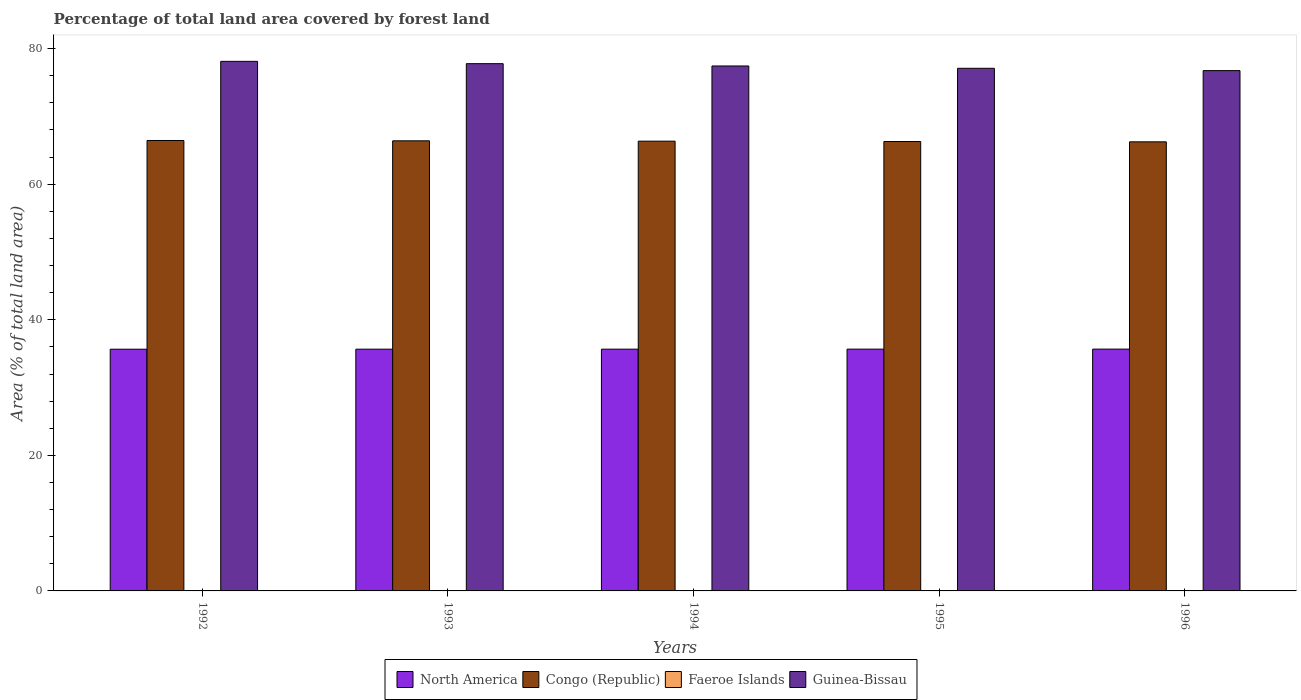How many groups of bars are there?
Provide a short and direct response. 5. Are the number of bars on each tick of the X-axis equal?
Give a very brief answer. Yes. How many bars are there on the 4th tick from the left?
Provide a short and direct response. 4. How many bars are there on the 2nd tick from the right?
Offer a very short reply. 4. What is the label of the 4th group of bars from the left?
Offer a very short reply. 1995. In how many cases, is the number of bars for a given year not equal to the number of legend labels?
Your answer should be compact. 0. What is the percentage of forest land in Congo (Republic) in 1995?
Provide a short and direct response. 66.3. Across all years, what is the maximum percentage of forest land in Congo (Republic)?
Give a very brief answer. 66.45. Across all years, what is the minimum percentage of forest land in North America?
Keep it short and to the point. 35.66. In which year was the percentage of forest land in North America minimum?
Provide a short and direct response. 1992. What is the total percentage of forest land in Faeroe Islands in the graph?
Your answer should be very brief. 0.29. What is the difference between the percentage of forest land in Guinea-Bissau in 1993 and that in 1996?
Offer a very short reply. 1.02. What is the difference between the percentage of forest land in Faeroe Islands in 1993 and the percentage of forest land in Congo (Republic) in 1994?
Your answer should be compact. -66.29. What is the average percentage of forest land in Guinea-Bissau per year?
Your response must be concise. 77.44. In the year 1995, what is the difference between the percentage of forest land in Congo (Republic) and percentage of forest land in Faeroe Islands?
Your answer should be compact. 66.24. In how many years, is the percentage of forest land in Guinea-Bissau greater than 64 %?
Offer a very short reply. 5. What is the ratio of the percentage of forest land in Congo (Republic) in 1992 to that in 1996?
Keep it short and to the point. 1. What is the difference between the highest and the second highest percentage of forest land in Congo (Republic)?
Make the answer very short. 0.05. What is the difference between the highest and the lowest percentage of forest land in Faeroe Islands?
Offer a terse response. 0. Is it the case that in every year, the sum of the percentage of forest land in Congo (Republic) and percentage of forest land in Faeroe Islands is greater than the sum of percentage of forest land in North America and percentage of forest land in Guinea-Bissau?
Give a very brief answer. Yes. What does the 4th bar from the left in 1994 represents?
Give a very brief answer. Guinea-Bissau. What does the 2nd bar from the right in 1996 represents?
Provide a succinct answer. Faeroe Islands. How many bars are there?
Provide a succinct answer. 20. Are all the bars in the graph horizontal?
Your answer should be compact. No. How many legend labels are there?
Your answer should be compact. 4. What is the title of the graph?
Provide a succinct answer. Percentage of total land area covered by forest land. Does "Europe(developing only)" appear as one of the legend labels in the graph?
Make the answer very short. No. What is the label or title of the Y-axis?
Make the answer very short. Area (% of total land area). What is the Area (% of total land area) in North America in 1992?
Give a very brief answer. 35.66. What is the Area (% of total land area) of Congo (Republic) in 1992?
Give a very brief answer. 66.45. What is the Area (% of total land area) in Faeroe Islands in 1992?
Provide a succinct answer. 0.06. What is the Area (% of total land area) of Guinea-Bissau in 1992?
Give a very brief answer. 78.12. What is the Area (% of total land area) in North America in 1993?
Provide a succinct answer. 35.66. What is the Area (% of total land area) of Congo (Republic) in 1993?
Make the answer very short. 66.4. What is the Area (% of total land area) of Faeroe Islands in 1993?
Give a very brief answer. 0.06. What is the Area (% of total land area) of Guinea-Bissau in 1993?
Offer a terse response. 77.78. What is the Area (% of total land area) in North America in 1994?
Your answer should be compact. 35.66. What is the Area (% of total land area) of Congo (Republic) in 1994?
Ensure brevity in your answer.  66.35. What is the Area (% of total land area) in Faeroe Islands in 1994?
Ensure brevity in your answer.  0.06. What is the Area (% of total land area) of Guinea-Bissau in 1994?
Make the answer very short. 77.44. What is the Area (% of total land area) in North America in 1995?
Keep it short and to the point. 35.67. What is the Area (% of total land area) in Congo (Republic) in 1995?
Give a very brief answer. 66.3. What is the Area (% of total land area) in Faeroe Islands in 1995?
Your answer should be compact. 0.06. What is the Area (% of total land area) in Guinea-Bissau in 1995?
Ensure brevity in your answer.  77.1. What is the Area (% of total land area) of North America in 1996?
Provide a succinct answer. 35.67. What is the Area (% of total land area) in Congo (Republic) in 1996?
Make the answer very short. 66.25. What is the Area (% of total land area) in Faeroe Islands in 1996?
Your answer should be compact. 0.06. What is the Area (% of total land area) of Guinea-Bissau in 1996?
Provide a succinct answer. 76.76. Across all years, what is the maximum Area (% of total land area) in North America?
Your answer should be compact. 35.67. Across all years, what is the maximum Area (% of total land area) of Congo (Republic)?
Provide a succinct answer. 66.45. Across all years, what is the maximum Area (% of total land area) in Faeroe Islands?
Your answer should be compact. 0.06. Across all years, what is the maximum Area (% of total land area) in Guinea-Bissau?
Your response must be concise. 78.12. Across all years, what is the minimum Area (% of total land area) in North America?
Offer a terse response. 35.66. Across all years, what is the minimum Area (% of total land area) in Congo (Republic)?
Your answer should be compact. 66.25. Across all years, what is the minimum Area (% of total land area) in Faeroe Islands?
Offer a terse response. 0.06. Across all years, what is the minimum Area (% of total land area) in Guinea-Bissau?
Your answer should be very brief. 76.76. What is the total Area (% of total land area) in North America in the graph?
Provide a succinct answer. 178.32. What is the total Area (% of total land area) in Congo (Republic) in the graph?
Your answer should be compact. 331.74. What is the total Area (% of total land area) in Faeroe Islands in the graph?
Keep it short and to the point. 0.29. What is the total Area (% of total land area) of Guinea-Bissau in the graph?
Keep it short and to the point. 387.2. What is the difference between the Area (% of total land area) in North America in 1992 and that in 1993?
Offer a terse response. -0. What is the difference between the Area (% of total land area) in Congo (Republic) in 1992 and that in 1993?
Make the answer very short. 0.05. What is the difference between the Area (% of total land area) of Faeroe Islands in 1992 and that in 1993?
Your answer should be very brief. 0. What is the difference between the Area (% of total land area) in Guinea-Bissau in 1992 and that in 1993?
Give a very brief answer. 0.34. What is the difference between the Area (% of total land area) in North America in 1992 and that in 1994?
Ensure brevity in your answer.  -0.01. What is the difference between the Area (% of total land area) in Congo (Republic) in 1992 and that in 1994?
Provide a short and direct response. 0.1. What is the difference between the Area (% of total land area) of Guinea-Bissau in 1992 and that in 1994?
Your answer should be very brief. 0.68. What is the difference between the Area (% of total land area) of North America in 1992 and that in 1995?
Make the answer very short. -0.01. What is the difference between the Area (% of total land area) in Congo (Republic) in 1992 and that in 1995?
Your response must be concise. 0.15. What is the difference between the Area (% of total land area) of Guinea-Bissau in 1992 and that in 1995?
Make the answer very short. 1.02. What is the difference between the Area (% of total land area) of North America in 1992 and that in 1996?
Your answer should be very brief. -0.01. What is the difference between the Area (% of total land area) in Congo (Republic) in 1992 and that in 1996?
Your answer should be compact. 0.2. What is the difference between the Area (% of total land area) in Faeroe Islands in 1992 and that in 1996?
Provide a short and direct response. 0. What is the difference between the Area (% of total land area) in Guinea-Bissau in 1992 and that in 1996?
Your answer should be very brief. 1.37. What is the difference between the Area (% of total land area) of North America in 1993 and that in 1994?
Provide a short and direct response. -0. What is the difference between the Area (% of total land area) of Congo (Republic) in 1993 and that in 1994?
Your answer should be compact. 0.05. What is the difference between the Area (% of total land area) of Faeroe Islands in 1993 and that in 1994?
Make the answer very short. 0. What is the difference between the Area (% of total land area) of Guinea-Bissau in 1993 and that in 1994?
Give a very brief answer. 0.34. What is the difference between the Area (% of total land area) in North America in 1993 and that in 1995?
Your answer should be compact. -0.01. What is the difference between the Area (% of total land area) of Congo (Republic) in 1993 and that in 1995?
Ensure brevity in your answer.  0.1. What is the difference between the Area (% of total land area) of Guinea-Bissau in 1993 and that in 1995?
Make the answer very short. 0.68. What is the difference between the Area (% of total land area) of North America in 1993 and that in 1996?
Your answer should be very brief. -0.01. What is the difference between the Area (% of total land area) in Congo (Republic) in 1993 and that in 1996?
Keep it short and to the point. 0.15. What is the difference between the Area (% of total land area) of Guinea-Bissau in 1993 and that in 1996?
Provide a succinct answer. 1.02. What is the difference between the Area (% of total land area) in North America in 1994 and that in 1995?
Offer a very short reply. -0. What is the difference between the Area (% of total land area) of Congo (Republic) in 1994 and that in 1995?
Your response must be concise. 0.05. What is the difference between the Area (% of total land area) of Faeroe Islands in 1994 and that in 1995?
Your response must be concise. 0. What is the difference between the Area (% of total land area) in Guinea-Bissau in 1994 and that in 1995?
Ensure brevity in your answer.  0.34. What is the difference between the Area (% of total land area) of North America in 1994 and that in 1996?
Provide a succinct answer. -0.01. What is the difference between the Area (% of total land area) in Congo (Republic) in 1994 and that in 1996?
Your response must be concise. 0.1. What is the difference between the Area (% of total land area) in Guinea-Bissau in 1994 and that in 1996?
Offer a terse response. 0.68. What is the difference between the Area (% of total land area) in North America in 1995 and that in 1996?
Ensure brevity in your answer.  -0. What is the difference between the Area (% of total land area) of Congo (Republic) in 1995 and that in 1996?
Your answer should be compact. 0.05. What is the difference between the Area (% of total land area) in Faeroe Islands in 1995 and that in 1996?
Provide a succinct answer. 0. What is the difference between the Area (% of total land area) in Guinea-Bissau in 1995 and that in 1996?
Ensure brevity in your answer.  0.34. What is the difference between the Area (% of total land area) of North America in 1992 and the Area (% of total land area) of Congo (Republic) in 1993?
Ensure brevity in your answer.  -30.74. What is the difference between the Area (% of total land area) of North America in 1992 and the Area (% of total land area) of Faeroe Islands in 1993?
Offer a very short reply. 35.6. What is the difference between the Area (% of total land area) of North America in 1992 and the Area (% of total land area) of Guinea-Bissau in 1993?
Your response must be concise. -42.12. What is the difference between the Area (% of total land area) in Congo (Republic) in 1992 and the Area (% of total land area) in Faeroe Islands in 1993?
Provide a succinct answer. 66.39. What is the difference between the Area (% of total land area) of Congo (Republic) in 1992 and the Area (% of total land area) of Guinea-Bissau in 1993?
Keep it short and to the point. -11.33. What is the difference between the Area (% of total land area) of Faeroe Islands in 1992 and the Area (% of total land area) of Guinea-Bissau in 1993?
Provide a short and direct response. -77.72. What is the difference between the Area (% of total land area) in North America in 1992 and the Area (% of total land area) in Congo (Republic) in 1994?
Keep it short and to the point. -30.69. What is the difference between the Area (% of total land area) of North America in 1992 and the Area (% of total land area) of Faeroe Islands in 1994?
Offer a terse response. 35.6. What is the difference between the Area (% of total land area) of North America in 1992 and the Area (% of total land area) of Guinea-Bissau in 1994?
Keep it short and to the point. -41.78. What is the difference between the Area (% of total land area) of Congo (Republic) in 1992 and the Area (% of total land area) of Faeroe Islands in 1994?
Give a very brief answer. 66.39. What is the difference between the Area (% of total land area) of Congo (Republic) in 1992 and the Area (% of total land area) of Guinea-Bissau in 1994?
Make the answer very short. -10.99. What is the difference between the Area (% of total land area) of Faeroe Islands in 1992 and the Area (% of total land area) of Guinea-Bissau in 1994?
Offer a very short reply. -77.38. What is the difference between the Area (% of total land area) of North America in 1992 and the Area (% of total land area) of Congo (Republic) in 1995?
Offer a terse response. -30.64. What is the difference between the Area (% of total land area) in North America in 1992 and the Area (% of total land area) in Faeroe Islands in 1995?
Give a very brief answer. 35.6. What is the difference between the Area (% of total land area) in North America in 1992 and the Area (% of total land area) in Guinea-Bissau in 1995?
Give a very brief answer. -41.44. What is the difference between the Area (% of total land area) of Congo (Republic) in 1992 and the Area (% of total land area) of Faeroe Islands in 1995?
Ensure brevity in your answer.  66.39. What is the difference between the Area (% of total land area) of Congo (Republic) in 1992 and the Area (% of total land area) of Guinea-Bissau in 1995?
Keep it short and to the point. -10.65. What is the difference between the Area (% of total land area) in Faeroe Islands in 1992 and the Area (% of total land area) in Guinea-Bissau in 1995?
Give a very brief answer. -77.04. What is the difference between the Area (% of total land area) of North America in 1992 and the Area (% of total land area) of Congo (Republic) in 1996?
Your answer should be compact. -30.59. What is the difference between the Area (% of total land area) in North America in 1992 and the Area (% of total land area) in Faeroe Islands in 1996?
Ensure brevity in your answer.  35.6. What is the difference between the Area (% of total land area) of North America in 1992 and the Area (% of total land area) of Guinea-Bissau in 1996?
Your response must be concise. -41.1. What is the difference between the Area (% of total land area) of Congo (Republic) in 1992 and the Area (% of total land area) of Faeroe Islands in 1996?
Provide a succinct answer. 66.39. What is the difference between the Area (% of total land area) of Congo (Republic) in 1992 and the Area (% of total land area) of Guinea-Bissau in 1996?
Make the answer very short. -10.31. What is the difference between the Area (% of total land area) of Faeroe Islands in 1992 and the Area (% of total land area) of Guinea-Bissau in 1996?
Offer a very short reply. -76.7. What is the difference between the Area (% of total land area) in North America in 1993 and the Area (% of total land area) in Congo (Republic) in 1994?
Your response must be concise. -30.69. What is the difference between the Area (% of total land area) of North America in 1993 and the Area (% of total land area) of Faeroe Islands in 1994?
Ensure brevity in your answer.  35.6. What is the difference between the Area (% of total land area) in North America in 1993 and the Area (% of total land area) in Guinea-Bissau in 1994?
Ensure brevity in your answer.  -41.78. What is the difference between the Area (% of total land area) of Congo (Republic) in 1993 and the Area (% of total land area) of Faeroe Islands in 1994?
Your response must be concise. 66.34. What is the difference between the Area (% of total land area) of Congo (Republic) in 1993 and the Area (% of total land area) of Guinea-Bissau in 1994?
Provide a short and direct response. -11.04. What is the difference between the Area (% of total land area) of Faeroe Islands in 1993 and the Area (% of total land area) of Guinea-Bissau in 1994?
Provide a short and direct response. -77.38. What is the difference between the Area (% of total land area) in North America in 1993 and the Area (% of total land area) in Congo (Republic) in 1995?
Provide a short and direct response. -30.64. What is the difference between the Area (% of total land area) of North America in 1993 and the Area (% of total land area) of Faeroe Islands in 1995?
Your answer should be compact. 35.6. What is the difference between the Area (% of total land area) in North America in 1993 and the Area (% of total land area) in Guinea-Bissau in 1995?
Ensure brevity in your answer.  -41.44. What is the difference between the Area (% of total land area) of Congo (Republic) in 1993 and the Area (% of total land area) of Faeroe Islands in 1995?
Your answer should be compact. 66.34. What is the difference between the Area (% of total land area) of Congo (Republic) in 1993 and the Area (% of total land area) of Guinea-Bissau in 1995?
Provide a short and direct response. -10.7. What is the difference between the Area (% of total land area) of Faeroe Islands in 1993 and the Area (% of total land area) of Guinea-Bissau in 1995?
Your answer should be compact. -77.04. What is the difference between the Area (% of total land area) in North America in 1993 and the Area (% of total land area) in Congo (Republic) in 1996?
Offer a terse response. -30.59. What is the difference between the Area (% of total land area) of North America in 1993 and the Area (% of total land area) of Faeroe Islands in 1996?
Offer a terse response. 35.6. What is the difference between the Area (% of total land area) in North America in 1993 and the Area (% of total land area) in Guinea-Bissau in 1996?
Your response must be concise. -41.1. What is the difference between the Area (% of total land area) in Congo (Republic) in 1993 and the Area (% of total land area) in Faeroe Islands in 1996?
Offer a terse response. 66.34. What is the difference between the Area (% of total land area) in Congo (Republic) in 1993 and the Area (% of total land area) in Guinea-Bissau in 1996?
Offer a very short reply. -10.36. What is the difference between the Area (% of total land area) in Faeroe Islands in 1993 and the Area (% of total land area) in Guinea-Bissau in 1996?
Give a very brief answer. -76.7. What is the difference between the Area (% of total land area) of North America in 1994 and the Area (% of total land area) of Congo (Republic) in 1995?
Keep it short and to the point. -30.63. What is the difference between the Area (% of total land area) of North America in 1994 and the Area (% of total land area) of Faeroe Islands in 1995?
Give a very brief answer. 35.61. What is the difference between the Area (% of total land area) of North America in 1994 and the Area (% of total land area) of Guinea-Bissau in 1995?
Offer a terse response. -41.43. What is the difference between the Area (% of total land area) of Congo (Republic) in 1994 and the Area (% of total land area) of Faeroe Islands in 1995?
Offer a very short reply. 66.29. What is the difference between the Area (% of total land area) in Congo (Republic) in 1994 and the Area (% of total land area) in Guinea-Bissau in 1995?
Give a very brief answer. -10.75. What is the difference between the Area (% of total land area) of Faeroe Islands in 1994 and the Area (% of total land area) of Guinea-Bissau in 1995?
Keep it short and to the point. -77.04. What is the difference between the Area (% of total land area) of North America in 1994 and the Area (% of total land area) of Congo (Republic) in 1996?
Give a very brief answer. -30.58. What is the difference between the Area (% of total land area) in North America in 1994 and the Area (% of total land area) in Faeroe Islands in 1996?
Offer a terse response. 35.61. What is the difference between the Area (% of total land area) in North America in 1994 and the Area (% of total land area) in Guinea-Bissau in 1996?
Make the answer very short. -41.09. What is the difference between the Area (% of total land area) in Congo (Republic) in 1994 and the Area (% of total land area) in Faeroe Islands in 1996?
Keep it short and to the point. 66.29. What is the difference between the Area (% of total land area) in Congo (Republic) in 1994 and the Area (% of total land area) in Guinea-Bissau in 1996?
Offer a very short reply. -10.41. What is the difference between the Area (% of total land area) of Faeroe Islands in 1994 and the Area (% of total land area) of Guinea-Bissau in 1996?
Keep it short and to the point. -76.7. What is the difference between the Area (% of total land area) of North America in 1995 and the Area (% of total land area) of Congo (Republic) in 1996?
Offer a very short reply. -30.58. What is the difference between the Area (% of total land area) in North America in 1995 and the Area (% of total land area) in Faeroe Islands in 1996?
Offer a very short reply. 35.61. What is the difference between the Area (% of total land area) in North America in 1995 and the Area (% of total land area) in Guinea-Bissau in 1996?
Your answer should be compact. -41.09. What is the difference between the Area (% of total land area) in Congo (Republic) in 1995 and the Area (% of total land area) in Faeroe Islands in 1996?
Your response must be concise. 66.24. What is the difference between the Area (% of total land area) of Congo (Republic) in 1995 and the Area (% of total land area) of Guinea-Bissau in 1996?
Provide a succinct answer. -10.46. What is the difference between the Area (% of total land area) in Faeroe Islands in 1995 and the Area (% of total land area) in Guinea-Bissau in 1996?
Your response must be concise. -76.7. What is the average Area (% of total land area) of North America per year?
Provide a short and direct response. 35.66. What is the average Area (% of total land area) of Congo (Republic) per year?
Offer a very short reply. 66.35. What is the average Area (% of total land area) of Faeroe Islands per year?
Offer a very short reply. 0.06. What is the average Area (% of total land area) of Guinea-Bissau per year?
Offer a terse response. 77.44. In the year 1992, what is the difference between the Area (% of total land area) of North America and Area (% of total land area) of Congo (Republic)?
Your response must be concise. -30.79. In the year 1992, what is the difference between the Area (% of total land area) in North America and Area (% of total land area) in Faeroe Islands?
Make the answer very short. 35.6. In the year 1992, what is the difference between the Area (% of total land area) in North America and Area (% of total land area) in Guinea-Bissau?
Keep it short and to the point. -42.46. In the year 1992, what is the difference between the Area (% of total land area) in Congo (Republic) and Area (% of total land area) in Faeroe Islands?
Offer a terse response. 66.39. In the year 1992, what is the difference between the Area (% of total land area) of Congo (Republic) and Area (% of total land area) of Guinea-Bissau?
Your response must be concise. -11.67. In the year 1992, what is the difference between the Area (% of total land area) of Faeroe Islands and Area (% of total land area) of Guinea-Bissau?
Provide a succinct answer. -78.06. In the year 1993, what is the difference between the Area (% of total land area) in North America and Area (% of total land area) in Congo (Republic)?
Provide a succinct answer. -30.74. In the year 1993, what is the difference between the Area (% of total land area) of North America and Area (% of total land area) of Faeroe Islands?
Provide a short and direct response. 35.6. In the year 1993, what is the difference between the Area (% of total land area) of North America and Area (% of total land area) of Guinea-Bissau?
Offer a terse response. -42.12. In the year 1993, what is the difference between the Area (% of total land area) of Congo (Republic) and Area (% of total land area) of Faeroe Islands?
Your answer should be very brief. 66.34. In the year 1993, what is the difference between the Area (% of total land area) in Congo (Republic) and Area (% of total land area) in Guinea-Bissau?
Provide a short and direct response. -11.38. In the year 1993, what is the difference between the Area (% of total land area) in Faeroe Islands and Area (% of total land area) in Guinea-Bissau?
Provide a short and direct response. -77.72. In the year 1994, what is the difference between the Area (% of total land area) in North America and Area (% of total land area) in Congo (Republic)?
Keep it short and to the point. -30.68. In the year 1994, what is the difference between the Area (% of total land area) in North America and Area (% of total land area) in Faeroe Islands?
Provide a short and direct response. 35.61. In the year 1994, what is the difference between the Area (% of total land area) in North America and Area (% of total land area) in Guinea-Bissau?
Offer a terse response. -41.77. In the year 1994, what is the difference between the Area (% of total land area) of Congo (Republic) and Area (% of total land area) of Faeroe Islands?
Keep it short and to the point. 66.29. In the year 1994, what is the difference between the Area (% of total land area) of Congo (Republic) and Area (% of total land area) of Guinea-Bissau?
Ensure brevity in your answer.  -11.09. In the year 1994, what is the difference between the Area (% of total land area) of Faeroe Islands and Area (% of total land area) of Guinea-Bissau?
Give a very brief answer. -77.38. In the year 1995, what is the difference between the Area (% of total land area) of North America and Area (% of total land area) of Congo (Republic)?
Provide a succinct answer. -30.63. In the year 1995, what is the difference between the Area (% of total land area) in North America and Area (% of total land area) in Faeroe Islands?
Give a very brief answer. 35.61. In the year 1995, what is the difference between the Area (% of total land area) in North America and Area (% of total land area) in Guinea-Bissau?
Provide a succinct answer. -41.43. In the year 1995, what is the difference between the Area (% of total land area) of Congo (Republic) and Area (% of total land area) of Faeroe Islands?
Your answer should be compact. 66.24. In the year 1995, what is the difference between the Area (% of total land area) of Congo (Republic) and Area (% of total land area) of Guinea-Bissau?
Make the answer very short. -10.8. In the year 1995, what is the difference between the Area (% of total land area) in Faeroe Islands and Area (% of total land area) in Guinea-Bissau?
Provide a short and direct response. -77.04. In the year 1996, what is the difference between the Area (% of total land area) of North America and Area (% of total land area) of Congo (Republic)?
Give a very brief answer. -30.58. In the year 1996, what is the difference between the Area (% of total land area) in North America and Area (% of total land area) in Faeroe Islands?
Make the answer very short. 35.61. In the year 1996, what is the difference between the Area (% of total land area) in North America and Area (% of total land area) in Guinea-Bissau?
Keep it short and to the point. -41.09. In the year 1996, what is the difference between the Area (% of total land area) of Congo (Republic) and Area (% of total land area) of Faeroe Islands?
Offer a terse response. 66.19. In the year 1996, what is the difference between the Area (% of total land area) in Congo (Republic) and Area (% of total land area) in Guinea-Bissau?
Make the answer very short. -10.51. In the year 1996, what is the difference between the Area (% of total land area) of Faeroe Islands and Area (% of total land area) of Guinea-Bissau?
Offer a terse response. -76.7. What is the ratio of the Area (% of total land area) in Congo (Republic) in 1992 to that in 1993?
Make the answer very short. 1. What is the ratio of the Area (% of total land area) in Faeroe Islands in 1992 to that in 1993?
Keep it short and to the point. 1. What is the ratio of the Area (% of total land area) of Congo (Republic) in 1992 to that in 1994?
Provide a short and direct response. 1. What is the ratio of the Area (% of total land area) in Faeroe Islands in 1992 to that in 1994?
Offer a terse response. 1. What is the ratio of the Area (% of total land area) of Guinea-Bissau in 1992 to that in 1994?
Ensure brevity in your answer.  1.01. What is the ratio of the Area (% of total land area) of North America in 1992 to that in 1995?
Keep it short and to the point. 1. What is the ratio of the Area (% of total land area) of Congo (Republic) in 1992 to that in 1995?
Provide a short and direct response. 1. What is the ratio of the Area (% of total land area) of Faeroe Islands in 1992 to that in 1995?
Make the answer very short. 1. What is the ratio of the Area (% of total land area) in Guinea-Bissau in 1992 to that in 1995?
Make the answer very short. 1.01. What is the ratio of the Area (% of total land area) of North America in 1992 to that in 1996?
Offer a terse response. 1. What is the ratio of the Area (% of total land area) of Congo (Republic) in 1992 to that in 1996?
Make the answer very short. 1. What is the ratio of the Area (% of total land area) of Guinea-Bissau in 1992 to that in 1996?
Offer a very short reply. 1.02. What is the ratio of the Area (% of total land area) of Faeroe Islands in 1993 to that in 1994?
Keep it short and to the point. 1. What is the ratio of the Area (% of total land area) in North America in 1993 to that in 1995?
Ensure brevity in your answer.  1. What is the ratio of the Area (% of total land area) of Congo (Republic) in 1993 to that in 1995?
Your response must be concise. 1. What is the ratio of the Area (% of total land area) of Guinea-Bissau in 1993 to that in 1995?
Your answer should be compact. 1.01. What is the ratio of the Area (% of total land area) in North America in 1993 to that in 1996?
Your answer should be very brief. 1. What is the ratio of the Area (% of total land area) in Congo (Republic) in 1993 to that in 1996?
Offer a very short reply. 1. What is the ratio of the Area (% of total land area) in Guinea-Bissau in 1993 to that in 1996?
Offer a terse response. 1.01. What is the ratio of the Area (% of total land area) in North America in 1994 to that in 1995?
Give a very brief answer. 1. What is the ratio of the Area (% of total land area) of Faeroe Islands in 1994 to that in 1995?
Provide a short and direct response. 1. What is the ratio of the Area (% of total land area) in Guinea-Bissau in 1994 to that in 1995?
Keep it short and to the point. 1. What is the ratio of the Area (% of total land area) of North America in 1994 to that in 1996?
Your response must be concise. 1. What is the ratio of the Area (% of total land area) in Guinea-Bissau in 1994 to that in 1996?
Your answer should be very brief. 1.01. What is the difference between the highest and the second highest Area (% of total land area) of North America?
Your response must be concise. 0. What is the difference between the highest and the second highest Area (% of total land area) of Congo (Republic)?
Give a very brief answer. 0.05. What is the difference between the highest and the second highest Area (% of total land area) of Faeroe Islands?
Provide a succinct answer. 0. What is the difference between the highest and the second highest Area (% of total land area) of Guinea-Bissau?
Keep it short and to the point. 0.34. What is the difference between the highest and the lowest Area (% of total land area) in North America?
Give a very brief answer. 0.01. What is the difference between the highest and the lowest Area (% of total land area) in Congo (Republic)?
Your response must be concise. 0.2. What is the difference between the highest and the lowest Area (% of total land area) in Faeroe Islands?
Make the answer very short. 0. What is the difference between the highest and the lowest Area (% of total land area) in Guinea-Bissau?
Ensure brevity in your answer.  1.37. 